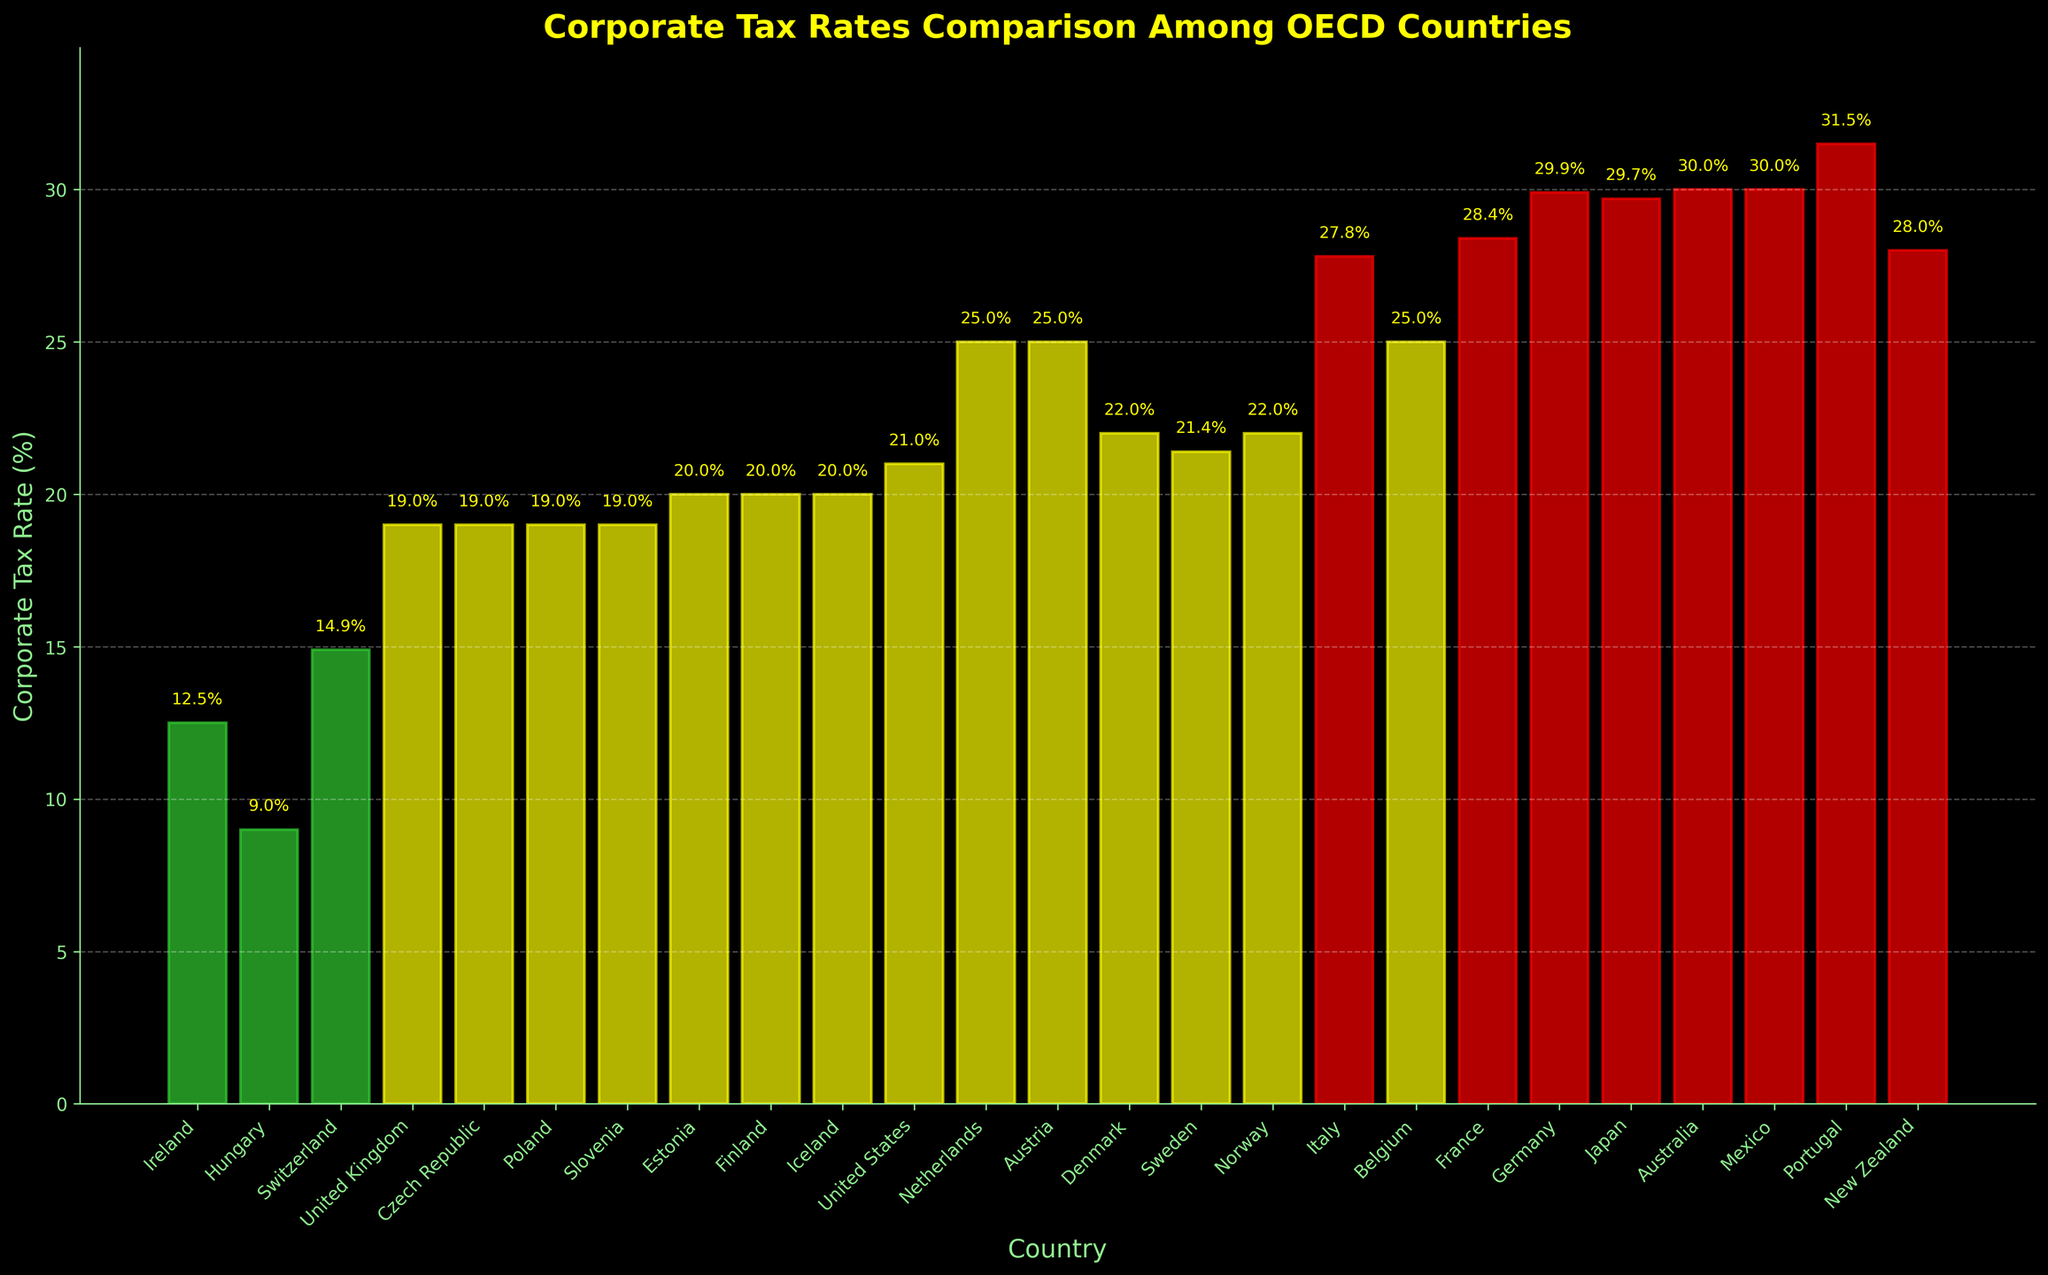Which country has the lowest corporate tax rate? By examining the height of the bars, we identify the shortest bar corresponding to Hungary, indicating the lowest tax rate of 9%.
Answer: Hungary Which country has the highest corporate tax rate? By observing the height of the bars, the tallest bar represents Portugal, indicating the highest tax rate of 31.5%.
Answer: Portugal How many countries have a corporate tax rate below 20%? Count the number of bars with heights corresponding to tax rates below 20%. These countries are Ireland, Hungary, Switzerland, and the United Kingdom, totaling 4 countries.
Answer: 4 What is the average corporate tax rate of Ireland, Hungary, and Switzerland? Sum the tax rates of these three countries (12.5 + 9.0 + 14.9 = 36.4) and then divide by 3 to get the average (36.4 / 3 = 12.13).
Answer: 12.13% Which countries have a corporate tax rate between 20% and 25%? Identify the bars with heights indicating tax rates within this range. These countries are Estonia, Finland, Iceland, the United States, Sweden, Austria, Belgium, and Denmark. Hence, there are 8 such countries.
Answer: Estonia, Finland, Iceland, United States, Sweden, Austria, Belgium, Denmark How does the corporate tax rate of France compare to Germany? Check the relative heights of the bars for France and Germany. France's bar is slightly shorter at 28.4%, while Germany's bar is at 29.9%.
Answer: France is lower What is the total corporate tax rate of the countries with green bars? The green bars represent countries with tax rates of 15% or less, namely Ireland (12.5%) and Hungary (9%). Summing these rates results in (12.5 + 9.0 = 21.5).
Answer: 21.5% Which country has a corporate tax rate equal to 30%? Identify the bar with a height corresponding to a 30% tax rate. This bar matches both Australia and Mexico, indicating that both countries have a 30% tax rate.
Answer: Australia, Mexico Which countries have corporate tax rates exactly at 19%? Locate the bars with heights indicating a 19% tax rate. These countries are the United Kingdom, Czech Republic, Poland, and Slovenia. There are 4 such countries.
Answer: United Kingdom, Czech Republic, Poland, Slovenia What is the difference in corporate tax rates between New Zealand and the Netherlands? Find the respective tax rates for New Zealand (28%) and the Netherlands (25%). Subtract the Netherlands' rate from New Zealand's (28 - 25 = 3).
Answer: 3% 